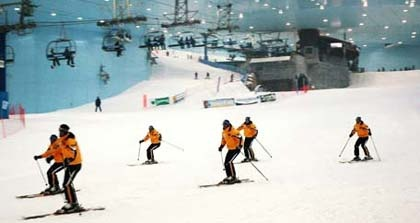Describe the objects in this image and their specific colors. I can see people in teal, black, brown, maroon, and red tones, people in teal, black, red, white, and brown tones, people in teal, black, white, gray, and brown tones, people in teal, black, ivory, gray, and darkgray tones, and people in teal, black, gray, maroon, and brown tones in this image. 